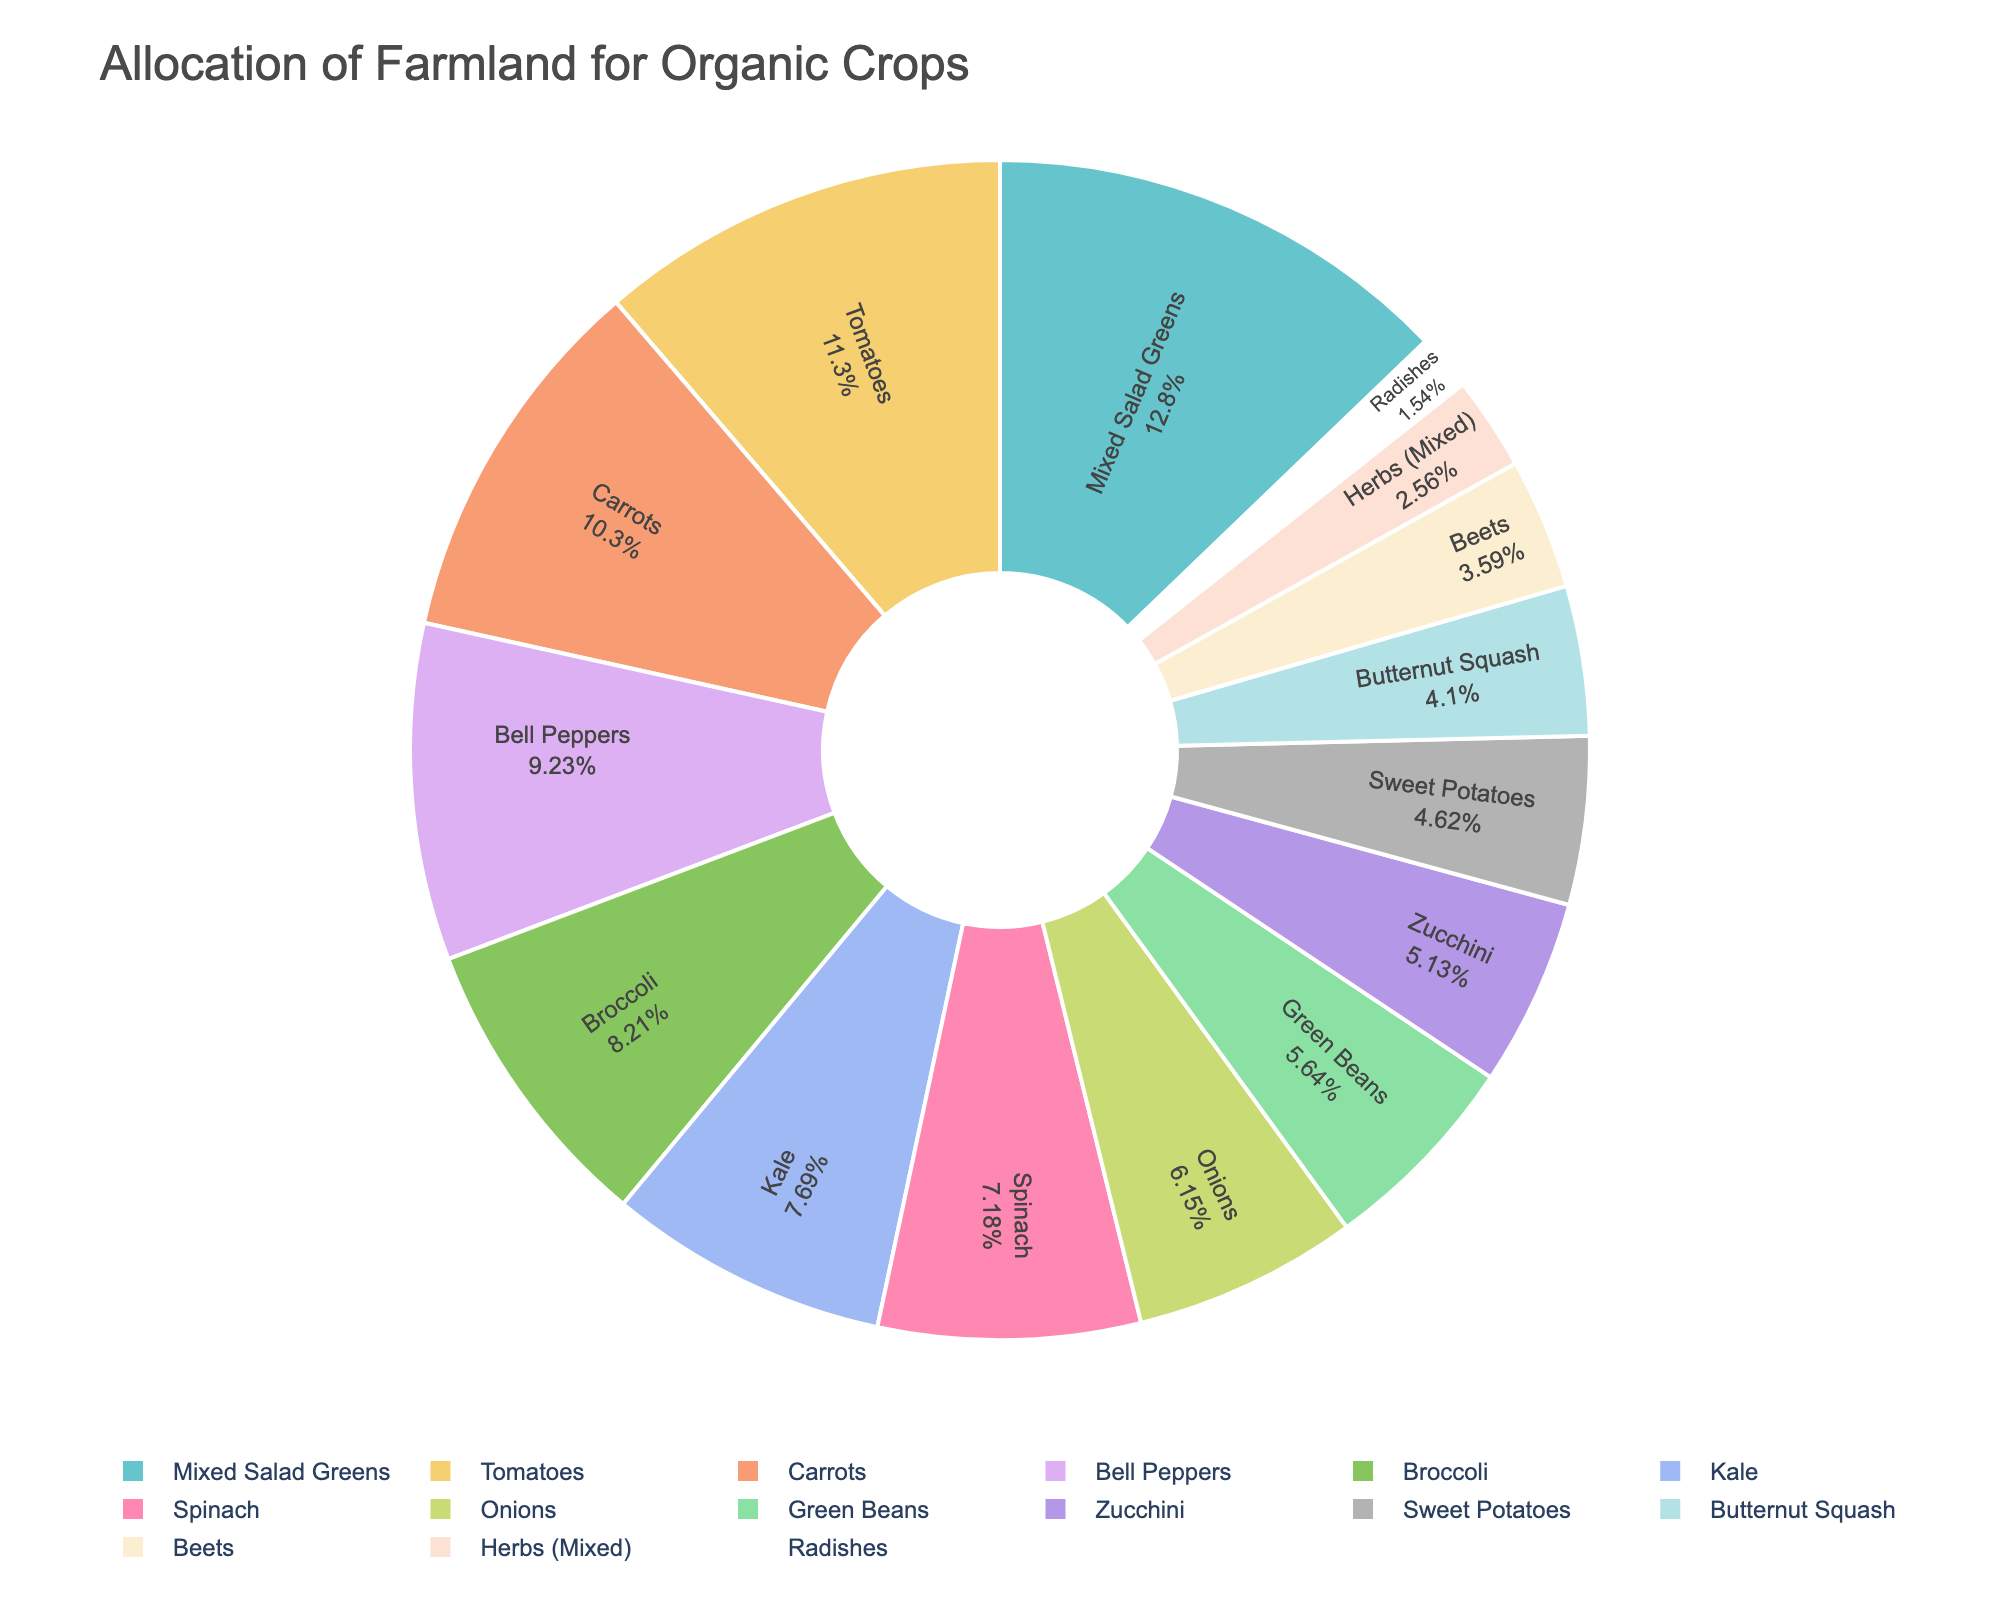What percentage of the farmland is allocated to Mixed Salad Greens? Look at the pie chart segment labeled "Mixed Salad Greens" to see the percentage it occupies.
Answer: 17.36% Which crop has the second largest allocation of farmland? Identify and compare the sizes of the pie chart segments. After "Mixed Salad Greens," the next largest segment is for "Tomatoes."
Answer: Tomatoes How much more farmland is allocated to Carrots compared to Radishes? Find the acreage for Carrots (20 acres) and Radishes (3 acres) and subtract the smaller value from the larger value: 20 - 3 = 17 acres.
Answer: 17 acres What is the total acreage of farmland allocated to Bell Peppers, Spinach, and Zucchini combined? Sum the acreages: Bell Peppers (18 acres) + Spinach (14 acres) + Zucchini (10 acres) = 18 + 14 + 10 = 42 acres.
Answer: 42 acres Are there more acres dedicated to Broccoli or Green Beans? By how much? Compare the acreages of Broccoli (16 acres) and Green Beans (11 acres). Subtract the smaller value from the larger value: 16 - 11 = 5 acres.
Answer: Broccoli by 5 acres Which crop occupies the smallest portion of the farmland? Identify the smallest segment on the pie chart, which corresponds to "Radishes" with 3 acres.
Answer: Radishes Do Sweet Potatoes and Beets together occupy more farmland than Onions alone? Sum the acreages of Sweet Potatoes (9 acres) and Beets (7 acres) to get 9 + 7 = 16 acres. Compare this with Onions' 12 acres. 16 > 12, so yes.
Answer: Yes What is the average acreage allocated to the top three largest crops? Identify the top three largest crops: Mixed Salad Greens (25 acres), Tomatoes (22 acres), and Bell Peppers (18 acres). Sum these and divide by 3: (25 + 22 + 18) / 3 = 65 / 3 ≈ 21.67 acres.
Answer: Approximately 21.67 acres 